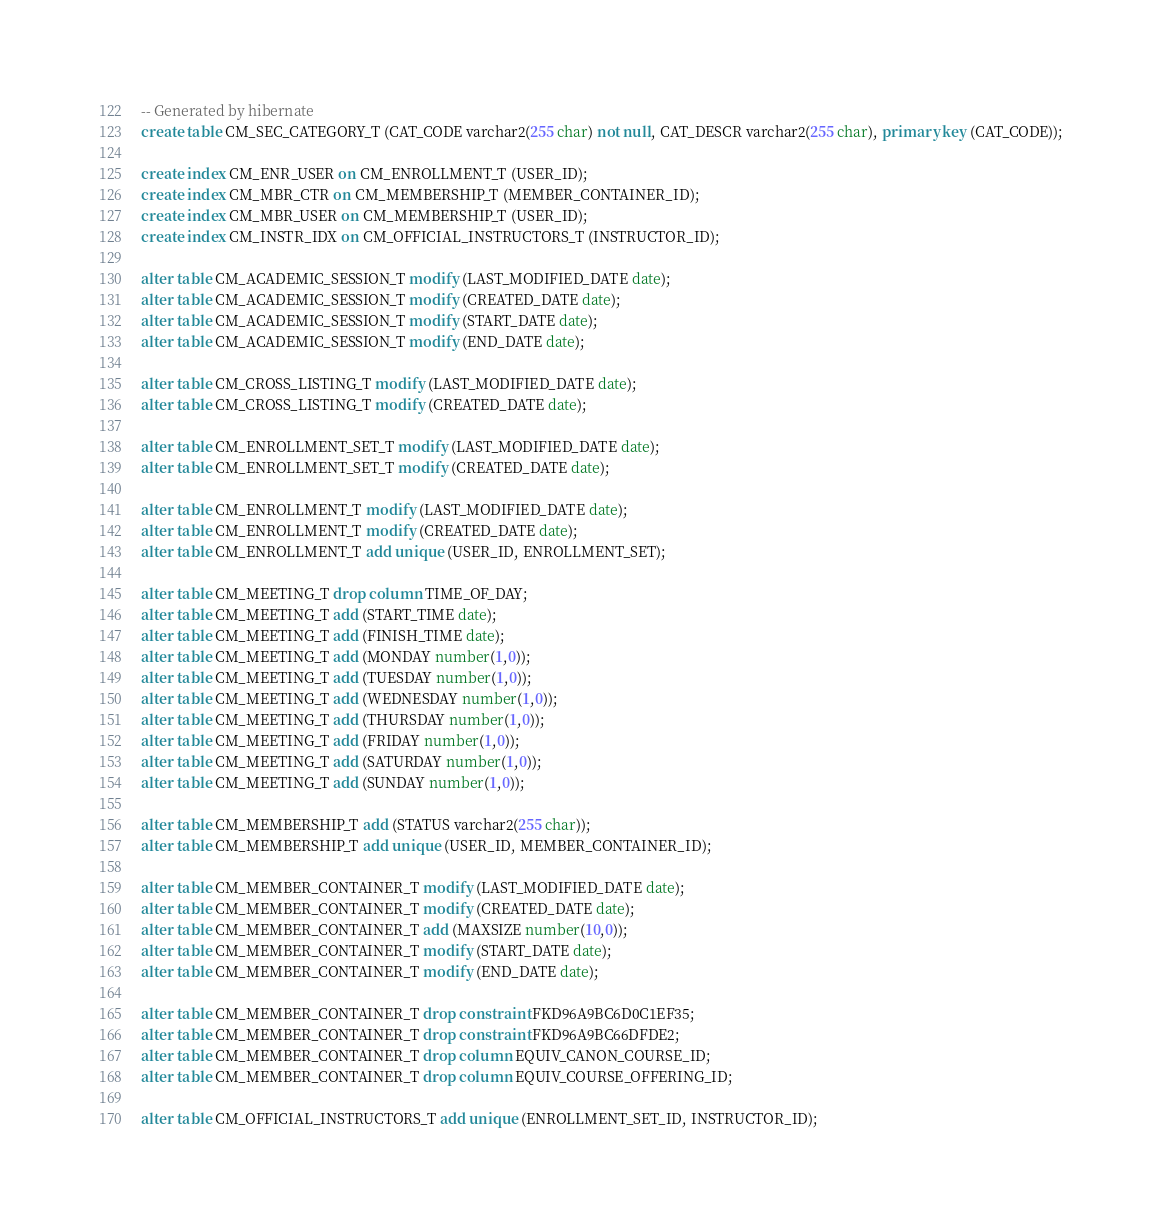<code> <loc_0><loc_0><loc_500><loc_500><_SQL_>-- Generated by hibernate
create table CM_SEC_CATEGORY_T (CAT_CODE varchar2(255 char) not null, CAT_DESCR varchar2(255 char), primary key (CAT_CODE));

create index CM_ENR_USER on CM_ENROLLMENT_T (USER_ID);
create index CM_MBR_CTR on CM_MEMBERSHIP_T (MEMBER_CONTAINER_ID);
create index CM_MBR_USER on CM_MEMBERSHIP_T (USER_ID);
create index CM_INSTR_IDX on CM_OFFICIAL_INSTRUCTORS_T (INSTRUCTOR_ID);

alter table CM_ACADEMIC_SESSION_T modify (LAST_MODIFIED_DATE date);
alter table CM_ACADEMIC_SESSION_T modify (CREATED_DATE date);
alter table CM_ACADEMIC_SESSION_T modify (START_DATE date);
alter table CM_ACADEMIC_SESSION_T modify (END_DATE date);

alter table CM_CROSS_LISTING_T modify (LAST_MODIFIED_DATE date);
alter table CM_CROSS_LISTING_T modify (CREATED_DATE date);

alter table CM_ENROLLMENT_SET_T modify (LAST_MODIFIED_DATE date);
alter table CM_ENROLLMENT_SET_T modify (CREATED_DATE date);

alter table CM_ENROLLMENT_T modify (LAST_MODIFIED_DATE date);
alter table CM_ENROLLMENT_T modify (CREATED_DATE date);
alter table CM_ENROLLMENT_T add unique (USER_ID, ENROLLMENT_SET);

alter table CM_MEETING_T drop column TIME_OF_DAY;
alter table CM_MEETING_T add (START_TIME date);
alter table CM_MEETING_T add (FINISH_TIME date);
alter table CM_MEETING_T add (MONDAY number(1,0));
alter table CM_MEETING_T add (TUESDAY number(1,0));
alter table CM_MEETING_T add (WEDNESDAY number(1,0));
alter table CM_MEETING_T add (THURSDAY number(1,0));
alter table CM_MEETING_T add (FRIDAY number(1,0));
alter table CM_MEETING_T add (SATURDAY number(1,0));
alter table CM_MEETING_T add (SUNDAY number(1,0));

alter table CM_MEMBERSHIP_T add (STATUS varchar2(255 char));
alter table CM_MEMBERSHIP_T add unique (USER_ID, MEMBER_CONTAINER_ID);

alter table CM_MEMBER_CONTAINER_T modify (LAST_MODIFIED_DATE date);
alter table CM_MEMBER_CONTAINER_T modify (CREATED_DATE date);
alter table CM_MEMBER_CONTAINER_T add (MAXSIZE number(10,0));
alter table CM_MEMBER_CONTAINER_T modify (START_DATE date);
alter table CM_MEMBER_CONTAINER_T modify (END_DATE date);

alter table CM_MEMBER_CONTAINER_T drop constraint FKD96A9BC6D0C1EF35;
alter table CM_MEMBER_CONTAINER_T drop constraint FKD96A9BC66DFDE2;
alter table CM_MEMBER_CONTAINER_T drop column EQUIV_CANON_COURSE_ID;
alter table CM_MEMBER_CONTAINER_T drop column EQUIV_COURSE_OFFERING_ID;

alter table CM_OFFICIAL_INSTRUCTORS_T add unique (ENROLLMENT_SET_ID, INSTRUCTOR_ID);

</code> 